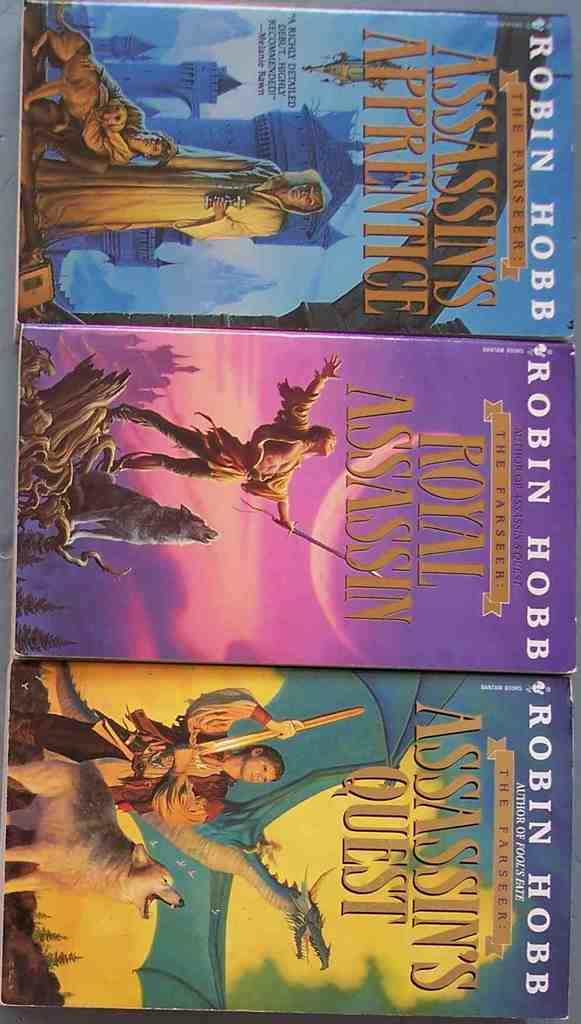<image>
Render a clear and concise summary of the photo. Three Robin Hobb novels are lined up, each with a different color cover. 